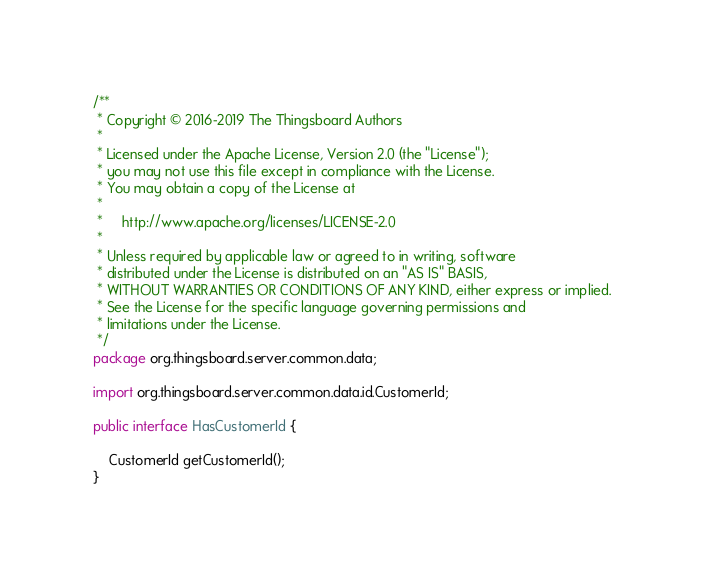Convert code to text. <code><loc_0><loc_0><loc_500><loc_500><_Java_>/**
 * Copyright © 2016-2019 The Thingsboard Authors
 *
 * Licensed under the Apache License, Version 2.0 (the "License");
 * you may not use this file except in compliance with the License.
 * You may obtain a copy of the License at
 *
 *     http://www.apache.org/licenses/LICENSE-2.0
 *
 * Unless required by applicable law or agreed to in writing, software
 * distributed under the License is distributed on an "AS IS" BASIS,
 * WITHOUT WARRANTIES OR CONDITIONS OF ANY KIND, either express or implied.
 * See the License for the specific language governing permissions and
 * limitations under the License.
 */
package org.thingsboard.server.common.data;

import org.thingsboard.server.common.data.id.CustomerId;

public interface HasCustomerId {

    CustomerId getCustomerId();
}
</code> 